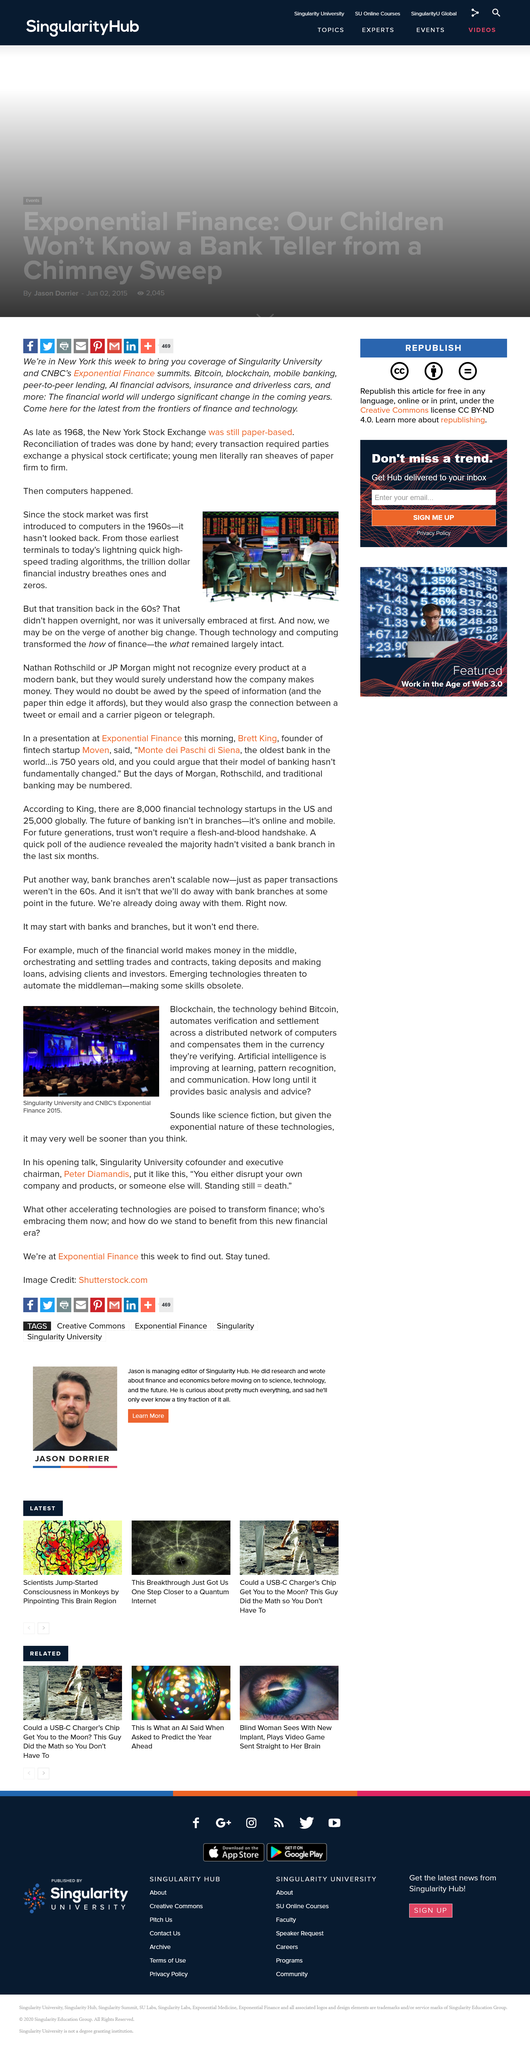Indicate a few pertinent items in this graphic. Technology transformed the way finance is conducted, fundamentally changing the "how" of finance. Singularity University, a university, was involved with the project. Computers were first introduced to the stock market in the 1960's, but it was not universally embraced at first. The image of the meeting was taken in 2015. In what year was the image of the meeting taken? The trading algorithms are lightning quick and high-speed. 